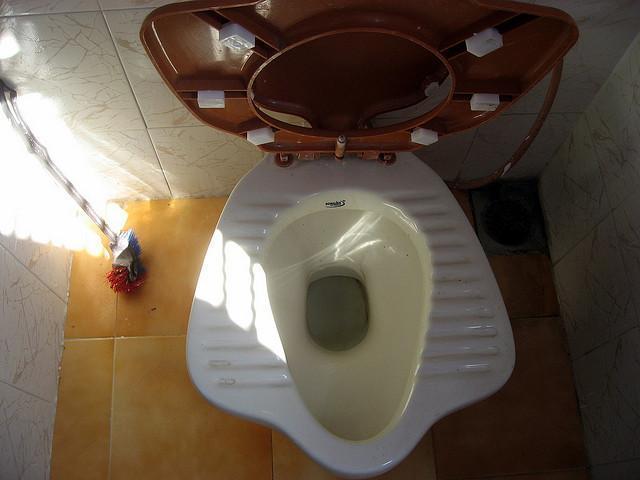How many people wear caps in the picture?
Give a very brief answer. 0. 